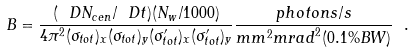<formula> <loc_0><loc_0><loc_500><loc_500>B = \frac { ( \ D N _ { c e n } / \ D t ) ( N _ { w } / 1 0 0 0 ) } { 4 \pi ^ { 2 } ( \sigma _ { t o t } ) _ { x } ( \sigma _ { t o t } ) _ { y } ( \sigma ^ { \prime } _ { t o t } ) _ { x } ( \sigma ^ { \prime } _ { t o t } ) _ { y } } \frac { p h o t o n s / s } { { m m } ^ { 2 } { m r a d } ^ { 2 } { ( 0 . 1 \% B W ) } } \ .</formula> 